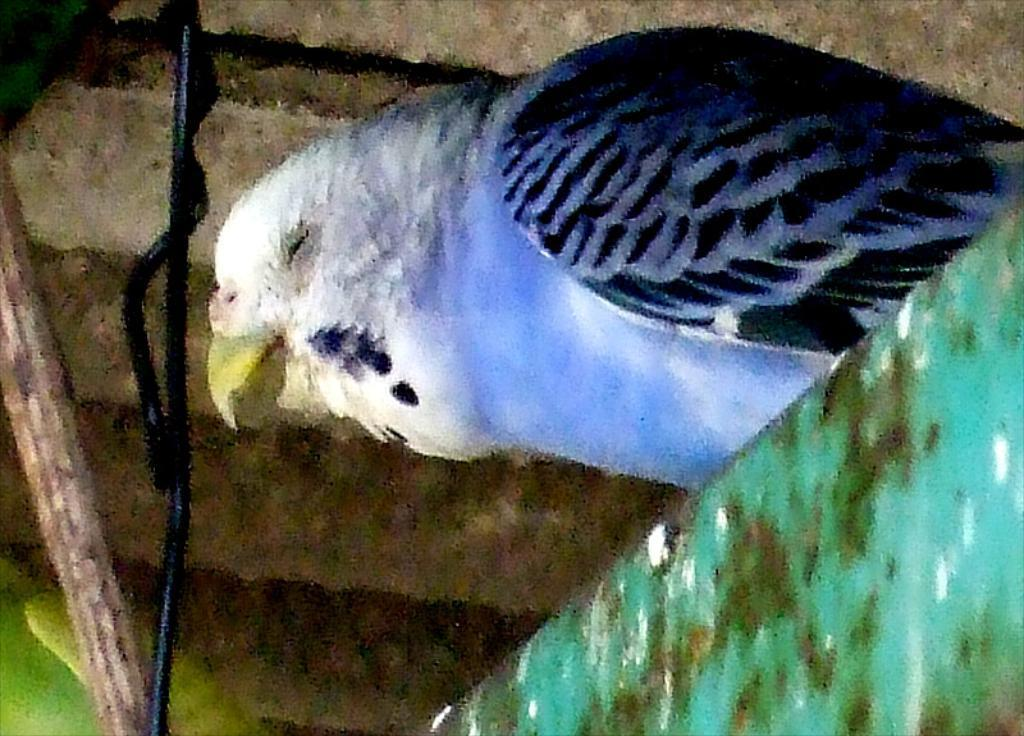What type of animal is present in the image? There is a bird in the image. Where is the bird located? The bird is on an object in the image. Can you describe the overall quality of the image? The image appears slightly blurred. What can be seen on the left side of the image? There is a branch on the left side of the image. How many lizards are crawling on the tooth in the image? There is no tooth or lizards present in the image; it features a bird on an object and a branch on the left side. 